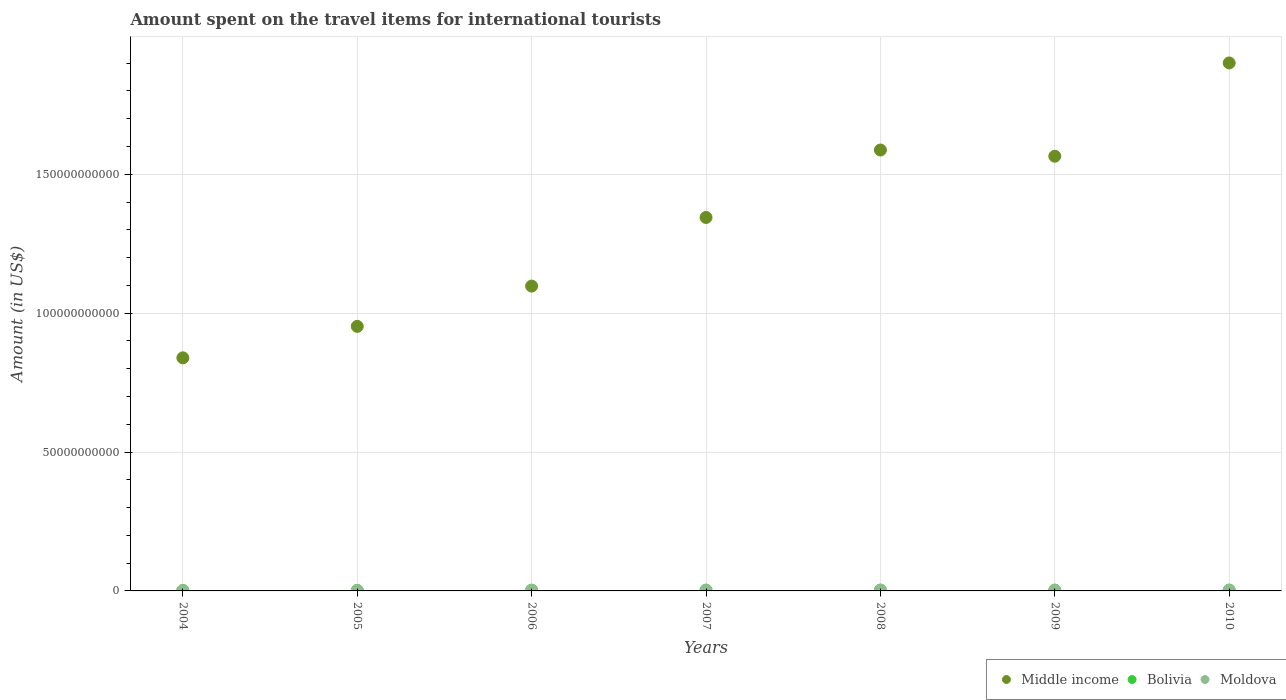How many different coloured dotlines are there?
Offer a very short reply. 3. Is the number of dotlines equal to the number of legend labels?
Give a very brief answer. Yes. What is the amount spent on the travel items for international tourists in Middle income in 2009?
Ensure brevity in your answer.  1.56e+11. Across all years, what is the maximum amount spent on the travel items for international tourists in Middle income?
Your answer should be compact. 1.90e+11. Across all years, what is the minimum amount spent on the travel items for international tourists in Moldova?
Your response must be concise. 1.13e+08. What is the total amount spent on the travel items for international tourists in Bolivia in the graph?
Your response must be concise. 1.81e+09. What is the difference between the amount spent on the travel items for international tourists in Bolivia in 2005 and that in 2008?
Provide a short and direct response. -9.50e+07. What is the difference between the amount spent on the travel items for international tourists in Moldova in 2006 and the amount spent on the travel items for international tourists in Middle income in 2004?
Provide a short and direct response. -8.37e+1. What is the average amount spent on the travel items for international tourists in Moldova per year?
Offer a terse response. 2.07e+08. In the year 2005, what is the difference between the amount spent on the travel items for international tourists in Moldova and amount spent on the travel items for international tourists in Bolivia?
Offer a very short reply. -4.50e+07. What is the ratio of the amount spent on the travel items for international tourists in Moldova in 2007 to that in 2008?
Your answer should be compact. 0.81. Is the amount spent on the travel items for international tourists in Middle income in 2006 less than that in 2009?
Provide a succinct answer. Yes. Is the difference between the amount spent on the travel items for international tourists in Moldova in 2004 and 2008 greater than the difference between the amount spent on the travel items for international tourists in Bolivia in 2004 and 2008?
Give a very brief answer. No. What is the difference between the highest and the second highest amount spent on the travel items for international tourists in Moldova?
Provide a succinct answer. 4.50e+07. What is the difference between the highest and the lowest amount spent on the travel items for international tourists in Bolivia?
Give a very brief answer. 1.49e+08. Is it the case that in every year, the sum of the amount spent on the travel items for international tourists in Moldova and amount spent on the travel items for international tourists in Middle income  is greater than the amount spent on the travel items for international tourists in Bolivia?
Your answer should be compact. Yes. Is the amount spent on the travel items for international tourists in Middle income strictly less than the amount spent on the travel items for international tourists in Moldova over the years?
Offer a terse response. No. How many dotlines are there?
Ensure brevity in your answer.  3. How many years are there in the graph?
Your answer should be compact. 7. What is the difference between two consecutive major ticks on the Y-axis?
Offer a terse response. 5.00e+1. Are the values on the major ticks of Y-axis written in scientific E-notation?
Offer a terse response. No. Does the graph contain any zero values?
Provide a short and direct response. No. Does the graph contain grids?
Your answer should be compact. Yes. Where does the legend appear in the graph?
Provide a succinct answer. Bottom right. How many legend labels are there?
Offer a terse response. 3. How are the legend labels stacked?
Offer a very short reply. Horizontal. What is the title of the graph?
Your answer should be very brief. Amount spent on the travel items for international tourists. Does "Macao" appear as one of the legend labels in the graph?
Your answer should be compact. No. What is the label or title of the Y-axis?
Offer a very short reply. Amount (in US$). What is the Amount (in US$) in Middle income in 2004?
Your response must be concise. 8.39e+1. What is the Amount (in US$) of Bolivia in 2004?
Offer a very short reply. 1.64e+08. What is the Amount (in US$) in Moldova in 2004?
Offer a terse response. 1.13e+08. What is the Amount (in US$) in Middle income in 2005?
Your answer should be very brief. 9.52e+1. What is the Amount (in US$) in Bolivia in 2005?
Ensure brevity in your answer.  1.86e+08. What is the Amount (in US$) in Moldova in 2005?
Give a very brief answer. 1.41e+08. What is the Amount (in US$) of Middle income in 2006?
Offer a terse response. 1.10e+11. What is the Amount (in US$) in Bolivia in 2006?
Your response must be concise. 2.73e+08. What is the Amount (in US$) in Moldova in 2006?
Provide a short and direct response. 1.90e+08. What is the Amount (in US$) in Middle income in 2007?
Provide a short and direct response. 1.34e+11. What is the Amount (in US$) in Bolivia in 2007?
Provide a short and direct response. 3.04e+08. What is the Amount (in US$) in Moldova in 2007?
Make the answer very short. 2.33e+08. What is the Amount (in US$) in Middle income in 2008?
Your answer should be compact. 1.59e+11. What is the Amount (in US$) of Bolivia in 2008?
Ensure brevity in your answer.  2.81e+08. What is the Amount (in US$) in Moldova in 2008?
Offer a terse response. 2.88e+08. What is the Amount (in US$) of Middle income in 2009?
Keep it short and to the point. 1.56e+11. What is the Amount (in US$) in Bolivia in 2009?
Keep it short and to the point. 2.90e+08. What is the Amount (in US$) in Moldova in 2009?
Offer a terse response. 2.43e+08. What is the Amount (in US$) in Middle income in 2010?
Your response must be concise. 1.90e+11. What is the Amount (in US$) of Bolivia in 2010?
Provide a short and direct response. 3.13e+08. What is the Amount (in US$) in Moldova in 2010?
Your answer should be compact. 2.41e+08. Across all years, what is the maximum Amount (in US$) of Middle income?
Your answer should be very brief. 1.90e+11. Across all years, what is the maximum Amount (in US$) in Bolivia?
Your answer should be compact. 3.13e+08. Across all years, what is the maximum Amount (in US$) in Moldova?
Your response must be concise. 2.88e+08. Across all years, what is the minimum Amount (in US$) in Middle income?
Your response must be concise. 8.39e+1. Across all years, what is the minimum Amount (in US$) of Bolivia?
Ensure brevity in your answer.  1.64e+08. Across all years, what is the minimum Amount (in US$) of Moldova?
Provide a succinct answer. 1.13e+08. What is the total Amount (in US$) in Middle income in the graph?
Your answer should be very brief. 9.29e+11. What is the total Amount (in US$) in Bolivia in the graph?
Offer a terse response. 1.81e+09. What is the total Amount (in US$) of Moldova in the graph?
Your response must be concise. 1.45e+09. What is the difference between the Amount (in US$) of Middle income in 2004 and that in 2005?
Keep it short and to the point. -1.13e+1. What is the difference between the Amount (in US$) in Bolivia in 2004 and that in 2005?
Your answer should be very brief. -2.20e+07. What is the difference between the Amount (in US$) of Moldova in 2004 and that in 2005?
Provide a succinct answer. -2.80e+07. What is the difference between the Amount (in US$) in Middle income in 2004 and that in 2006?
Your answer should be very brief. -2.58e+1. What is the difference between the Amount (in US$) of Bolivia in 2004 and that in 2006?
Your response must be concise. -1.09e+08. What is the difference between the Amount (in US$) in Moldova in 2004 and that in 2006?
Keep it short and to the point. -7.70e+07. What is the difference between the Amount (in US$) in Middle income in 2004 and that in 2007?
Make the answer very short. -5.05e+1. What is the difference between the Amount (in US$) in Bolivia in 2004 and that in 2007?
Keep it short and to the point. -1.40e+08. What is the difference between the Amount (in US$) in Moldova in 2004 and that in 2007?
Your answer should be very brief. -1.20e+08. What is the difference between the Amount (in US$) of Middle income in 2004 and that in 2008?
Make the answer very short. -7.48e+1. What is the difference between the Amount (in US$) in Bolivia in 2004 and that in 2008?
Your answer should be compact. -1.17e+08. What is the difference between the Amount (in US$) of Moldova in 2004 and that in 2008?
Provide a short and direct response. -1.75e+08. What is the difference between the Amount (in US$) in Middle income in 2004 and that in 2009?
Ensure brevity in your answer.  -7.26e+1. What is the difference between the Amount (in US$) of Bolivia in 2004 and that in 2009?
Give a very brief answer. -1.26e+08. What is the difference between the Amount (in US$) of Moldova in 2004 and that in 2009?
Ensure brevity in your answer.  -1.30e+08. What is the difference between the Amount (in US$) of Middle income in 2004 and that in 2010?
Your response must be concise. -1.06e+11. What is the difference between the Amount (in US$) in Bolivia in 2004 and that in 2010?
Provide a short and direct response. -1.49e+08. What is the difference between the Amount (in US$) in Moldova in 2004 and that in 2010?
Your response must be concise. -1.28e+08. What is the difference between the Amount (in US$) in Middle income in 2005 and that in 2006?
Offer a very short reply. -1.45e+1. What is the difference between the Amount (in US$) in Bolivia in 2005 and that in 2006?
Offer a terse response. -8.70e+07. What is the difference between the Amount (in US$) of Moldova in 2005 and that in 2006?
Provide a succinct answer. -4.90e+07. What is the difference between the Amount (in US$) in Middle income in 2005 and that in 2007?
Give a very brief answer. -3.92e+1. What is the difference between the Amount (in US$) in Bolivia in 2005 and that in 2007?
Provide a short and direct response. -1.18e+08. What is the difference between the Amount (in US$) in Moldova in 2005 and that in 2007?
Provide a succinct answer. -9.20e+07. What is the difference between the Amount (in US$) in Middle income in 2005 and that in 2008?
Offer a terse response. -6.35e+1. What is the difference between the Amount (in US$) of Bolivia in 2005 and that in 2008?
Ensure brevity in your answer.  -9.50e+07. What is the difference between the Amount (in US$) of Moldova in 2005 and that in 2008?
Offer a very short reply. -1.47e+08. What is the difference between the Amount (in US$) in Middle income in 2005 and that in 2009?
Make the answer very short. -6.12e+1. What is the difference between the Amount (in US$) of Bolivia in 2005 and that in 2009?
Provide a short and direct response. -1.04e+08. What is the difference between the Amount (in US$) of Moldova in 2005 and that in 2009?
Provide a short and direct response. -1.02e+08. What is the difference between the Amount (in US$) of Middle income in 2005 and that in 2010?
Your response must be concise. -9.48e+1. What is the difference between the Amount (in US$) of Bolivia in 2005 and that in 2010?
Make the answer very short. -1.27e+08. What is the difference between the Amount (in US$) in Moldova in 2005 and that in 2010?
Provide a succinct answer. -1.00e+08. What is the difference between the Amount (in US$) in Middle income in 2006 and that in 2007?
Your response must be concise. -2.47e+1. What is the difference between the Amount (in US$) of Bolivia in 2006 and that in 2007?
Give a very brief answer. -3.10e+07. What is the difference between the Amount (in US$) in Moldova in 2006 and that in 2007?
Provide a succinct answer. -4.30e+07. What is the difference between the Amount (in US$) of Middle income in 2006 and that in 2008?
Your answer should be very brief. -4.90e+1. What is the difference between the Amount (in US$) in Bolivia in 2006 and that in 2008?
Offer a terse response. -8.00e+06. What is the difference between the Amount (in US$) of Moldova in 2006 and that in 2008?
Ensure brevity in your answer.  -9.80e+07. What is the difference between the Amount (in US$) of Middle income in 2006 and that in 2009?
Keep it short and to the point. -4.67e+1. What is the difference between the Amount (in US$) in Bolivia in 2006 and that in 2009?
Offer a very short reply. -1.70e+07. What is the difference between the Amount (in US$) in Moldova in 2006 and that in 2009?
Keep it short and to the point. -5.30e+07. What is the difference between the Amount (in US$) in Middle income in 2006 and that in 2010?
Offer a very short reply. -8.03e+1. What is the difference between the Amount (in US$) in Bolivia in 2006 and that in 2010?
Your response must be concise. -4.00e+07. What is the difference between the Amount (in US$) of Moldova in 2006 and that in 2010?
Provide a succinct answer. -5.10e+07. What is the difference between the Amount (in US$) in Middle income in 2007 and that in 2008?
Your answer should be very brief. -2.43e+1. What is the difference between the Amount (in US$) in Bolivia in 2007 and that in 2008?
Make the answer very short. 2.30e+07. What is the difference between the Amount (in US$) in Moldova in 2007 and that in 2008?
Ensure brevity in your answer.  -5.50e+07. What is the difference between the Amount (in US$) of Middle income in 2007 and that in 2009?
Offer a terse response. -2.20e+1. What is the difference between the Amount (in US$) of Bolivia in 2007 and that in 2009?
Keep it short and to the point. 1.40e+07. What is the difference between the Amount (in US$) in Moldova in 2007 and that in 2009?
Make the answer very short. -1.00e+07. What is the difference between the Amount (in US$) of Middle income in 2007 and that in 2010?
Give a very brief answer. -5.56e+1. What is the difference between the Amount (in US$) in Bolivia in 2007 and that in 2010?
Give a very brief answer. -9.00e+06. What is the difference between the Amount (in US$) in Moldova in 2007 and that in 2010?
Ensure brevity in your answer.  -8.00e+06. What is the difference between the Amount (in US$) of Middle income in 2008 and that in 2009?
Provide a succinct answer. 2.23e+09. What is the difference between the Amount (in US$) in Bolivia in 2008 and that in 2009?
Ensure brevity in your answer.  -9.00e+06. What is the difference between the Amount (in US$) of Moldova in 2008 and that in 2009?
Your answer should be very brief. 4.50e+07. What is the difference between the Amount (in US$) in Middle income in 2008 and that in 2010?
Give a very brief answer. -3.13e+1. What is the difference between the Amount (in US$) in Bolivia in 2008 and that in 2010?
Your response must be concise. -3.20e+07. What is the difference between the Amount (in US$) in Moldova in 2008 and that in 2010?
Ensure brevity in your answer.  4.70e+07. What is the difference between the Amount (in US$) of Middle income in 2009 and that in 2010?
Your response must be concise. -3.36e+1. What is the difference between the Amount (in US$) in Bolivia in 2009 and that in 2010?
Your response must be concise. -2.30e+07. What is the difference between the Amount (in US$) in Moldova in 2009 and that in 2010?
Your response must be concise. 2.00e+06. What is the difference between the Amount (in US$) in Middle income in 2004 and the Amount (in US$) in Bolivia in 2005?
Provide a succinct answer. 8.37e+1. What is the difference between the Amount (in US$) of Middle income in 2004 and the Amount (in US$) of Moldova in 2005?
Make the answer very short. 8.38e+1. What is the difference between the Amount (in US$) of Bolivia in 2004 and the Amount (in US$) of Moldova in 2005?
Your response must be concise. 2.30e+07. What is the difference between the Amount (in US$) in Middle income in 2004 and the Amount (in US$) in Bolivia in 2006?
Offer a terse response. 8.36e+1. What is the difference between the Amount (in US$) in Middle income in 2004 and the Amount (in US$) in Moldova in 2006?
Give a very brief answer. 8.37e+1. What is the difference between the Amount (in US$) of Bolivia in 2004 and the Amount (in US$) of Moldova in 2006?
Your answer should be compact. -2.60e+07. What is the difference between the Amount (in US$) in Middle income in 2004 and the Amount (in US$) in Bolivia in 2007?
Offer a very short reply. 8.36e+1. What is the difference between the Amount (in US$) in Middle income in 2004 and the Amount (in US$) in Moldova in 2007?
Your response must be concise. 8.37e+1. What is the difference between the Amount (in US$) in Bolivia in 2004 and the Amount (in US$) in Moldova in 2007?
Offer a terse response. -6.90e+07. What is the difference between the Amount (in US$) of Middle income in 2004 and the Amount (in US$) of Bolivia in 2008?
Provide a short and direct response. 8.36e+1. What is the difference between the Amount (in US$) of Middle income in 2004 and the Amount (in US$) of Moldova in 2008?
Offer a terse response. 8.36e+1. What is the difference between the Amount (in US$) in Bolivia in 2004 and the Amount (in US$) in Moldova in 2008?
Provide a short and direct response. -1.24e+08. What is the difference between the Amount (in US$) of Middle income in 2004 and the Amount (in US$) of Bolivia in 2009?
Give a very brief answer. 8.36e+1. What is the difference between the Amount (in US$) in Middle income in 2004 and the Amount (in US$) in Moldova in 2009?
Ensure brevity in your answer.  8.37e+1. What is the difference between the Amount (in US$) in Bolivia in 2004 and the Amount (in US$) in Moldova in 2009?
Your answer should be very brief. -7.90e+07. What is the difference between the Amount (in US$) of Middle income in 2004 and the Amount (in US$) of Bolivia in 2010?
Provide a succinct answer. 8.36e+1. What is the difference between the Amount (in US$) in Middle income in 2004 and the Amount (in US$) in Moldova in 2010?
Your response must be concise. 8.37e+1. What is the difference between the Amount (in US$) in Bolivia in 2004 and the Amount (in US$) in Moldova in 2010?
Your answer should be compact. -7.70e+07. What is the difference between the Amount (in US$) of Middle income in 2005 and the Amount (in US$) of Bolivia in 2006?
Provide a short and direct response. 9.50e+1. What is the difference between the Amount (in US$) in Middle income in 2005 and the Amount (in US$) in Moldova in 2006?
Make the answer very short. 9.50e+1. What is the difference between the Amount (in US$) of Middle income in 2005 and the Amount (in US$) of Bolivia in 2007?
Offer a terse response. 9.49e+1. What is the difference between the Amount (in US$) of Middle income in 2005 and the Amount (in US$) of Moldova in 2007?
Make the answer very short. 9.50e+1. What is the difference between the Amount (in US$) of Bolivia in 2005 and the Amount (in US$) of Moldova in 2007?
Provide a succinct answer. -4.70e+07. What is the difference between the Amount (in US$) of Middle income in 2005 and the Amount (in US$) of Bolivia in 2008?
Keep it short and to the point. 9.50e+1. What is the difference between the Amount (in US$) of Middle income in 2005 and the Amount (in US$) of Moldova in 2008?
Provide a succinct answer. 9.49e+1. What is the difference between the Amount (in US$) of Bolivia in 2005 and the Amount (in US$) of Moldova in 2008?
Your answer should be compact. -1.02e+08. What is the difference between the Amount (in US$) of Middle income in 2005 and the Amount (in US$) of Bolivia in 2009?
Your answer should be very brief. 9.49e+1. What is the difference between the Amount (in US$) of Middle income in 2005 and the Amount (in US$) of Moldova in 2009?
Your answer should be very brief. 9.50e+1. What is the difference between the Amount (in US$) of Bolivia in 2005 and the Amount (in US$) of Moldova in 2009?
Provide a short and direct response. -5.70e+07. What is the difference between the Amount (in US$) of Middle income in 2005 and the Amount (in US$) of Bolivia in 2010?
Your answer should be very brief. 9.49e+1. What is the difference between the Amount (in US$) in Middle income in 2005 and the Amount (in US$) in Moldova in 2010?
Ensure brevity in your answer.  9.50e+1. What is the difference between the Amount (in US$) in Bolivia in 2005 and the Amount (in US$) in Moldova in 2010?
Your response must be concise. -5.50e+07. What is the difference between the Amount (in US$) in Middle income in 2006 and the Amount (in US$) in Bolivia in 2007?
Your response must be concise. 1.09e+11. What is the difference between the Amount (in US$) of Middle income in 2006 and the Amount (in US$) of Moldova in 2007?
Your answer should be very brief. 1.10e+11. What is the difference between the Amount (in US$) of Bolivia in 2006 and the Amount (in US$) of Moldova in 2007?
Keep it short and to the point. 4.00e+07. What is the difference between the Amount (in US$) of Middle income in 2006 and the Amount (in US$) of Bolivia in 2008?
Provide a succinct answer. 1.09e+11. What is the difference between the Amount (in US$) of Middle income in 2006 and the Amount (in US$) of Moldova in 2008?
Give a very brief answer. 1.09e+11. What is the difference between the Amount (in US$) of Bolivia in 2006 and the Amount (in US$) of Moldova in 2008?
Your response must be concise. -1.50e+07. What is the difference between the Amount (in US$) in Middle income in 2006 and the Amount (in US$) in Bolivia in 2009?
Give a very brief answer. 1.09e+11. What is the difference between the Amount (in US$) of Middle income in 2006 and the Amount (in US$) of Moldova in 2009?
Ensure brevity in your answer.  1.09e+11. What is the difference between the Amount (in US$) in Bolivia in 2006 and the Amount (in US$) in Moldova in 2009?
Ensure brevity in your answer.  3.00e+07. What is the difference between the Amount (in US$) of Middle income in 2006 and the Amount (in US$) of Bolivia in 2010?
Give a very brief answer. 1.09e+11. What is the difference between the Amount (in US$) in Middle income in 2006 and the Amount (in US$) in Moldova in 2010?
Your answer should be very brief. 1.09e+11. What is the difference between the Amount (in US$) in Bolivia in 2006 and the Amount (in US$) in Moldova in 2010?
Your response must be concise. 3.20e+07. What is the difference between the Amount (in US$) in Middle income in 2007 and the Amount (in US$) in Bolivia in 2008?
Offer a very short reply. 1.34e+11. What is the difference between the Amount (in US$) in Middle income in 2007 and the Amount (in US$) in Moldova in 2008?
Make the answer very short. 1.34e+11. What is the difference between the Amount (in US$) in Bolivia in 2007 and the Amount (in US$) in Moldova in 2008?
Ensure brevity in your answer.  1.60e+07. What is the difference between the Amount (in US$) of Middle income in 2007 and the Amount (in US$) of Bolivia in 2009?
Provide a short and direct response. 1.34e+11. What is the difference between the Amount (in US$) of Middle income in 2007 and the Amount (in US$) of Moldova in 2009?
Offer a very short reply. 1.34e+11. What is the difference between the Amount (in US$) in Bolivia in 2007 and the Amount (in US$) in Moldova in 2009?
Your answer should be very brief. 6.10e+07. What is the difference between the Amount (in US$) of Middle income in 2007 and the Amount (in US$) of Bolivia in 2010?
Provide a short and direct response. 1.34e+11. What is the difference between the Amount (in US$) of Middle income in 2007 and the Amount (in US$) of Moldova in 2010?
Your answer should be very brief. 1.34e+11. What is the difference between the Amount (in US$) of Bolivia in 2007 and the Amount (in US$) of Moldova in 2010?
Give a very brief answer. 6.30e+07. What is the difference between the Amount (in US$) in Middle income in 2008 and the Amount (in US$) in Bolivia in 2009?
Make the answer very short. 1.58e+11. What is the difference between the Amount (in US$) in Middle income in 2008 and the Amount (in US$) in Moldova in 2009?
Make the answer very short. 1.58e+11. What is the difference between the Amount (in US$) in Bolivia in 2008 and the Amount (in US$) in Moldova in 2009?
Provide a succinct answer. 3.80e+07. What is the difference between the Amount (in US$) in Middle income in 2008 and the Amount (in US$) in Bolivia in 2010?
Make the answer very short. 1.58e+11. What is the difference between the Amount (in US$) of Middle income in 2008 and the Amount (in US$) of Moldova in 2010?
Keep it short and to the point. 1.58e+11. What is the difference between the Amount (in US$) of Bolivia in 2008 and the Amount (in US$) of Moldova in 2010?
Make the answer very short. 4.00e+07. What is the difference between the Amount (in US$) of Middle income in 2009 and the Amount (in US$) of Bolivia in 2010?
Your answer should be compact. 1.56e+11. What is the difference between the Amount (in US$) in Middle income in 2009 and the Amount (in US$) in Moldova in 2010?
Offer a terse response. 1.56e+11. What is the difference between the Amount (in US$) in Bolivia in 2009 and the Amount (in US$) in Moldova in 2010?
Ensure brevity in your answer.  4.90e+07. What is the average Amount (in US$) in Middle income per year?
Your answer should be very brief. 1.33e+11. What is the average Amount (in US$) in Bolivia per year?
Offer a terse response. 2.59e+08. What is the average Amount (in US$) in Moldova per year?
Provide a short and direct response. 2.07e+08. In the year 2004, what is the difference between the Amount (in US$) of Middle income and Amount (in US$) of Bolivia?
Keep it short and to the point. 8.37e+1. In the year 2004, what is the difference between the Amount (in US$) in Middle income and Amount (in US$) in Moldova?
Make the answer very short. 8.38e+1. In the year 2004, what is the difference between the Amount (in US$) in Bolivia and Amount (in US$) in Moldova?
Keep it short and to the point. 5.10e+07. In the year 2005, what is the difference between the Amount (in US$) in Middle income and Amount (in US$) in Bolivia?
Your answer should be compact. 9.50e+1. In the year 2005, what is the difference between the Amount (in US$) in Middle income and Amount (in US$) in Moldova?
Your response must be concise. 9.51e+1. In the year 2005, what is the difference between the Amount (in US$) of Bolivia and Amount (in US$) of Moldova?
Provide a succinct answer. 4.50e+07. In the year 2006, what is the difference between the Amount (in US$) of Middle income and Amount (in US$) of Bolivia?
Ensure brevity in your answer.  1.09e+11. In the year 2006, what is the difference between the Amount (in US$) in Middle income and Amount (in US$) in Moldova?
Provide a short and direct response. 1.10e+11. In the year 2006, what is the difference between the Amount (in US$) in Bolivia and Amount (in US$) in Moldova?
Your answer should be very brief. 8.30e+07. In the year 2007, what is the difference between the Amount (in US$) of Middle income and Amount (in US$) of Bolivia?
Your answer should be very brief. 1.34e+11. In the year 2007, what is the difference between the Amount (in US$) of Middle income and Amount (in US$) of Moldova?
Your answer should be compact. 1.34e+11. In the year 2007, what is the difference between the Amount (in US$) of Bolivia and Amount (in US$) of Moldova?
Provide a short and direct response. 7.10e+07. In the year 2008, what is the difference between the Amount (in US$) of Middle income and Amount (in US$) of Bolivia?
Your answer should be very brief. 1.58e+11. In the year 2008, what is the difference between the Amount (in US$) in Middle income and Amount (in US$) in Moldova?
Provide a short and direct response. 1.58e+11. In the year 2008, what is the difference between the Amount (in US$) of Bolivia and Amount (in US$) of Moldova?
Your answer should be compact. -7.00e+06. In the year 2009, what is the difference between the Amount (in US$) in Middle income and Amount (in US$) in Bolivia?
Ensure brevity in your answer.  1.56e+11. In the year 2009, what is the difference between the Amount (in US$) of Middle income and Amount (in US$) of Moldova?
Give a very brief answer. 1.56e+11. In the year 2009, what is the difference between the Amount (in US$) in Bolivia and Amount (in US$) in Moldova?
Provide a short and direct response. 4.70e+07. In the year 2010, what is the difference between the Amount (in US$) in Middle income and Amount (in US$) in Bolivia?
Make the answer very short. 1.90e+11. In the year 2010, what is the difference between the Amount (in US$) of Middle income and Amount (in US$) of Moldova?
Ensure brevity in your answer.  1.90e+11. In the year 2010, what is the difference between the Amount (in US$) of Bolivia and Amount (in US$) of Moldova?
Offer a terse response. 7.20e+07. What is the ratio of the Amount (in US$) of Middle income in 2004 to that in 2005?
Ensure brevity in your answer.  0.88. What is the ratio of the Amount (in US$) of Bolivia in 2004 to that in 2005?
Your response must be concise. 0.88. What is the ratio of the Amount (in US$) in Moldova in 2004 to that in 2005?
Offer a terse response. 0.8. What is the ratio of the Amount (in US$) of Middle income in 2004 to that in 2006?
Keep it short and to the point. 0.76. What is the ratio of the Amount (in US$) in Bolivia in 2004 to that in 2006?
Your answer should be very brief. 0.6. What is the ratio of the Amount (in US$) of Moldova in 2004 to that in 2006?
Your answer should be very brief. 0.59. What is the ratio of the Amount (in US$) in Middle income in 2004 to that in 2007?
Offer a very short reply. 0.62. What is the ratio of the Amount (in US$) of Bolivia in 2004 to that in 2007?
Ensure brevity in your answer.  0.54. What is the ratio of the Amount (in US$) of Moldova in 2004 to that in 2007?
Your response must be concise. 0.48. What is the ratio of the Amount (in US$) in Middle income in 2004 to that in 2008?
Offer a very short reply. 0.53. What is the ratio of the Amount (in US$) in Bolivia in 2004 to that in 2008?
Ensure brevity in your answer.  0.58. What is the ratio of the Amount (in US$) in Moldova in 2004 to that in 2008?
Your answer should be very brief. 0.39. What is the ratio of the Amount (in US$) in Middle income in 2004 to that in 2009?
Your response must be concise. 0.54. What is the ratio of the Amount (in US$) of Bolivia in 2004 to that in 2009?
Your answer should be compact. 0.57. What is the ratio of the Amount (in US$) of Moldova in 2004 to that in 2009?
Your answer should be compact. 0.47. What is the ratio of the Amount (in US$) of Middle income in 2004 to that in 2010?
Provide a short and direct response. 0.44. What is the ratio of the Amount (in US$) of Bolivia in 2004 to that in 2010?
Give a very brief answer. 0.52. What is the ratio of the Amount (in US$) of Moldova in 2004 to that in 2010?
Make the answer very short. 0.47. What is the ratio of the Amount (in US$) in Middle income in 2005 to that in 2006?
Offer a terse response. 0.87. What is the ratio of the Amount (in US$) in Bolivia in 2005 to that in 2006?
Ensure brevity in your answer.  0.68. What is the ratio of the Amount (in US$) of Moldova in 2005 to that in 2006?
Ensure brevity in your answer.  0.74. What is the ratio of the Amount (in US$) in Middle income in 2005 to that in 2007?
Offer a terse response. 0.71. What is the ratio of the Amount (in US$) of Bolivia in 2005 to that in 2007?
Provide a short and direct response. 0.61. What is the ratio of the Amount (in US$) in Moldova in 2005 to that in 2007?
Keep it short and to the point. 0.61. What is the ratio of the Amount (in US$) of Middle income in 2005 to that in 2008?
Provide a short and direct response. 0.6. What is the ratio of the Amount (in US$) of Bolivia in 2005 to that in 2008?
Provide a short and direct response. 0.66. What is the ratio of the Amount (in US$) in Moldova in 2005 to that in 2008?
Ensure brevity in your answer.  0.49. What is the ratio of the Amount (in US$) in Middle income in 2005 to that in 2009?
Give a very brief answer. 0.61. What is the ratio of the Amount (in US$) of Bolivia in 2005 to that in 2009?
Your answer should be very brief. 0.64. What is the ratio of the Amount (in US$) in Moldova in 2005 to that in 2009?
Offer a terse response. 0.58. What is the ratio of the Amount (in US$) of Middle income in 2005 to that in 2010?
Your answer should be very brief. 0.5. What is the ratio of the Amount (in US$) in Bolivia in 2005 to that in 2010?
Offer a terse response. 0.59. What is the ratio of the Amount (in US$) of Moldova in 2005 to that in 2010?
Provide a short and direct response. 0.59. What is the ratio of the Amount (in US$) in Middle income in 2006 to that in 2007?
Your answer should be compact. 0.82. What is the ratio of the Amount (in US$) in Bolivia in 2006 to that in 2007?
Give a very brief answer. 0.9. What is the ratio of the Amount (in US$) in Moldova in 2006 to that in 2007?
Ensure brevity in your answer.  0.82. What is the ratio of the Amount (in US$) of Middle income in 2006 to that in 2008?
Provide a succinct answer. 0.69. What is the ratio of the Amount (in US$) of Bolivia in 2006 to that in 2008?
Ensure brevity in your answer.  0.97. What is the ratio of the Amount (in US$) of Moldova in 2006 to that in 2008?
Keep it short and to the point. 0.66. What is the ratio of the Amount (in US$) of Middle income in 2006 to that in 2009?
Give a very brief answer. 0.7. What is the ratio of the Amount (in US$) of Bolivia in 2006 to that in 2009?
Your response must be concise. 0.94. What is the ratio of the Amount (in US$) in Moldova in 2006 to that in 2009?
Make the answer very short. 0.78. What is the ratio of the Amount (in US$) in Middle income in 2006 to that in 2010?
Ensure brevity in your answer.  0.58. What is the ratio of the Amount (in US$) in Bolivia in 2006 to that in 2010?
Ensure brevity in your answer.  0.87. What is the ratio of the Amount (in US$) of Moldova in 2006 to that in 2010?
Provide a short and direct response. 0.79. What is the ratio of the Amount (in US$) of Middle income in 2007 to that in 2008?
Your answer should be compact. 0.85. What is the ratio of the Amount (in US$) of Bolivia in 2007 to that in 2008?
Provide a succinct answer. 1.08. What is the ratio of the Amount (in US$) of Moldova in 2007 to that in 2008?
Ensure brevity in your answer.  0.81. What is the ratio of the Amount (in US$) of Middle income in 2007 to that in 2009?
Ensure brevity in your answer.  0.86. What is the ratio of the Amount (in US$) in Bolivia in 2007 to that in 2009?
Your answer should be very brief. 1.05. What is the ratio of the Amount (in US$) of Moldova in 2007 to that in 2009?
Make the answer very short. 0.96. What is the ratio of the Amount (in US$) in Middle income in 2007 to that in 2010?
Keep it short and to the point. 0.71. What is the ratio of the Amount (in US$) of Bolivia in 2007 to that in 2010?
Provide a short and direct response. 0.97. What is the ratio of the Amount (in US$) in Moldova in 2007 to that in 2010?
Make the answer very short. 0.97. What is the ratio of the Amount (in US$) of Middle income in 2008 to that in 2009?
Make the answer very short. 1.01. What is the ratio of the Amount (in US$) in Moldova in 2008 to that in 2009?
Offer a terse response. 1.19. What is the ratio of the Amount (in US$) of Middle income in 2008 to that in 2010?
Your answer should be very brief. 0.84. What is the ratio of the Amount (in US$) in Bolivia in 2008 to that in 2010?
Make the answer very short. 0.9. What is the ratio of the Amount (in US$) in Moldova in 2008 to that in 2010?
Give a very brief answer. 1.2. What is the ratio of the Amount (in US$) in Middle income in 2009 to that in 2010?
Provide a short and direct response. 0.82. What is the ratio of the Amount (in US$) of Bolivia in 2009 to that in 2010?
Provide a short and direct response. 0.93. What is the ratio of the Amount (in US$) of Moldova in 2009 to that in 2010?
Make the answer very short. 1.01. What is the difference between the highest and the second highest Amount (in US$) in Middle income?
Provide a succinct answer. 3.13e+1. What is the difference between the highest and the second highest Amount (in US$) of Bolivia?
Your answer should be compact. 9.00e+06. What is the difference between the highest and the second highest Amount (in US$) of Moldova?
Ensure brevity in your answer.  4.50e+07. What is the difference between the highest and the lowest Amount (in US$) in Middle income?
Your answer should be very brief. 1.06e+11. What is the difference between the highest and the lowest Amount (in US$) of Bolivia?
Provide a short and direct response. 1.49e+08. What is the difference between the highest and the lowest Amount (in US$) of Moldova?
Keep it short and to the point. 1.75e+08. 